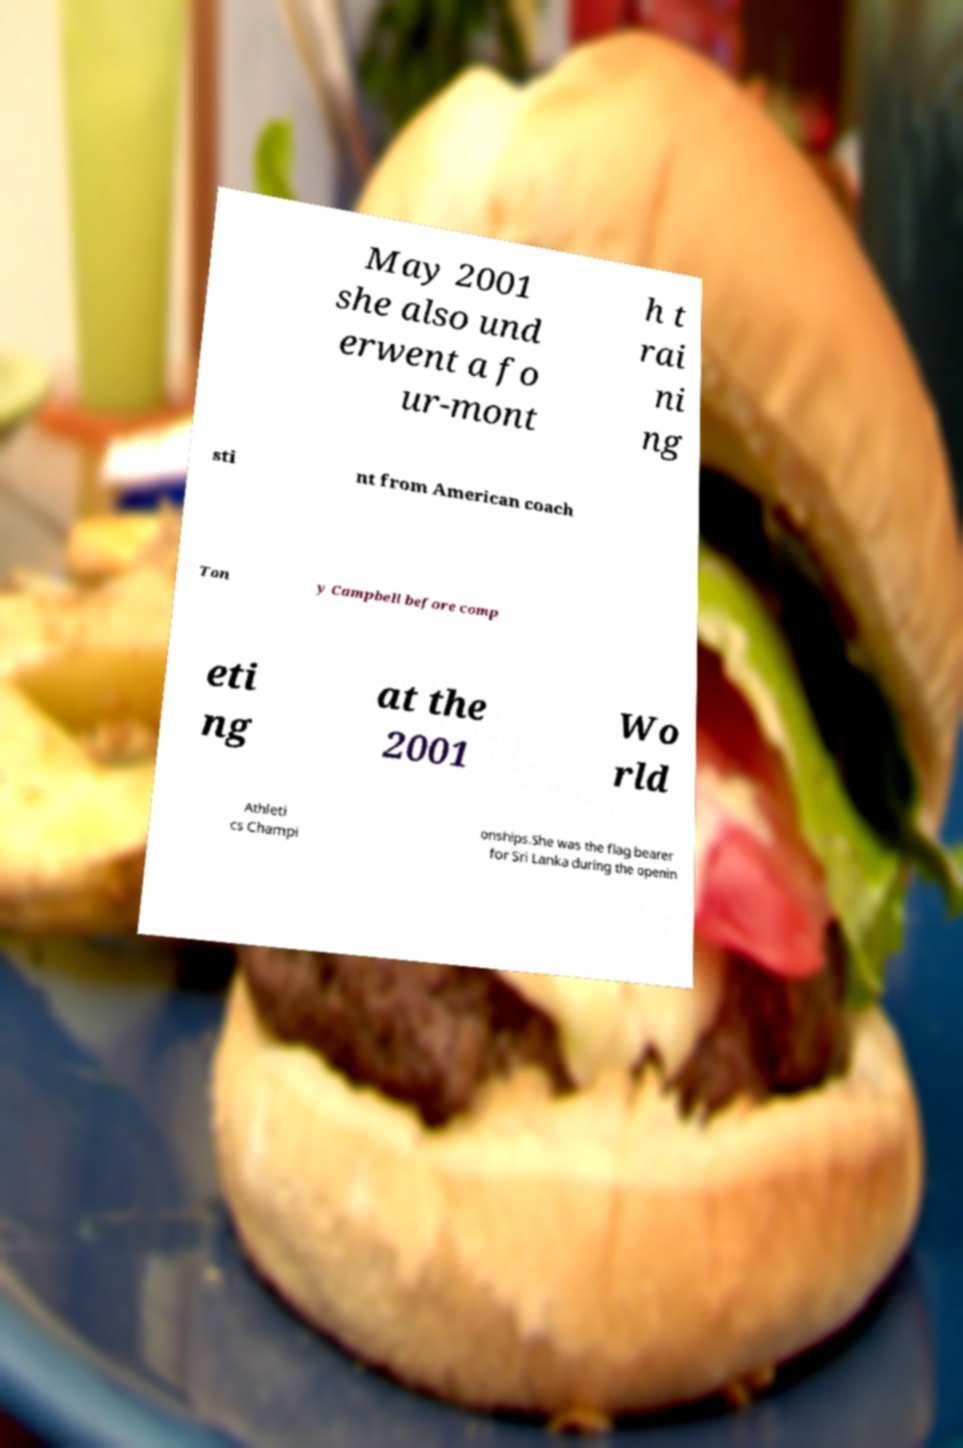Please identify and transcribe the text found in this image. May 2001 she also und erwent a fo ur-mont h t rai ni ng sti nt from American coach Ton y Campbell before comp eti ng at the 2001 Wo rld Athleti cs Champi onships.She was the flag bearer for Sri Lanka during the openin 